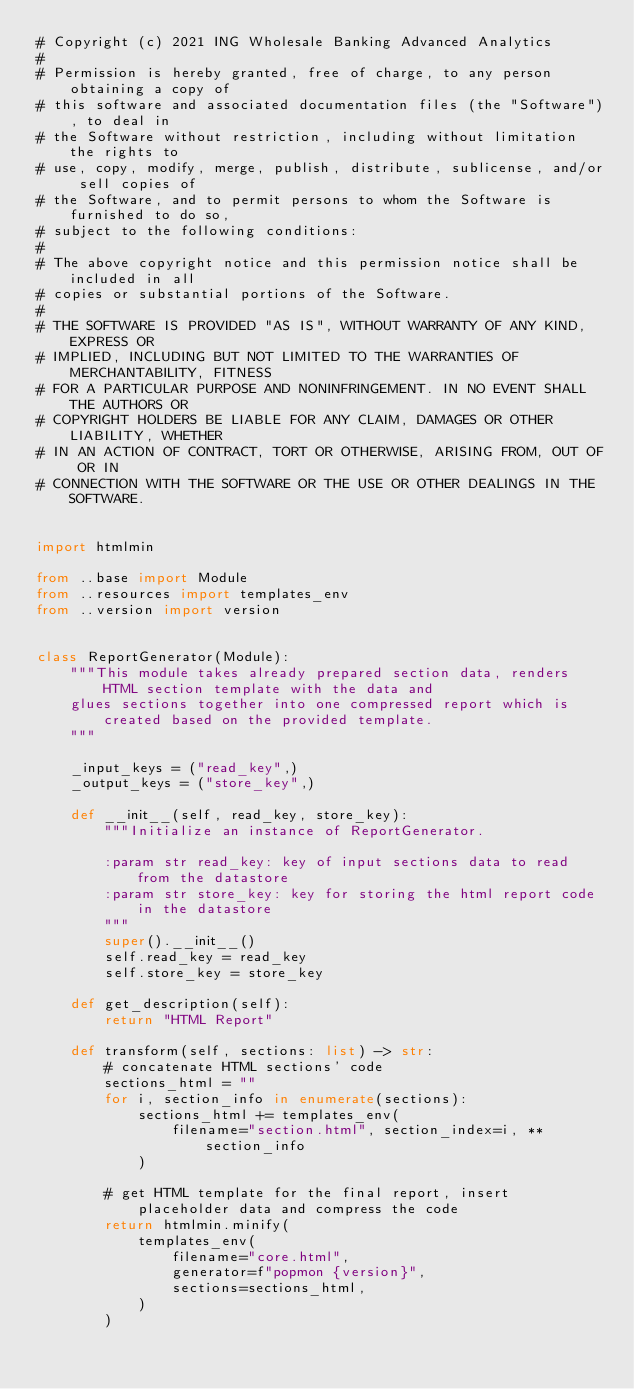Convert code to text. <code><loc_0><loc_0><loc_500><loc_500><_Python_># Copyright (c) 2021 ING Wholesale Banking Advanced Analytics
#
# Permission is hereby granted, free of charge, to any person obtaining a copy of
# this software and associated documentation files (the "Software"), to deal in
# the Software without restriction, including without limitation the rights to
# use, copy, modify, merge, publish, distribute, sublicense, and/or sell copies of
# the Software, and to permit persons to whom the Software is furnished to do so,
# subject to the following conditions:
#
# The above copyright notice and this permission notice shall be included in all
# copies or substantial portions of the Software.
#
# THE SOFTWARE IS PROVIDED "AS IS", WITHOUT WARRANTY OF ANY KIND, EXPRESS OR
# IMPLIED, INCLUDING BUT NOT LIMITED TO THE WARRANTIES OF MERCHANTABILITY, FITNESS
# FOR A PARTICULAR PURPOSE AND NONINFRINGEMENT. IN NO EVENT SHALL THE AUTHORS OR
# COPYRIGHT HOLDERS BE LIABLE FOR ANY CLAIM, DAMAGES OR OTHER LIABILITY, WHETHER
# IN AN ACTION OF CONTRACT, TORT OR OTHERWISE, ARISING FROM, OUT OF OR IN
# CONNECTION WITH THE SOFTWARE OR THE USE OR OTHER DEALINGS IN THE SOFTWARE.


import htmlmin

from ..base import Module
from ..resources import templates_env
from ..version import version


class ReportGenerator(Module):
    """This module takes already prepared section data, renders HTML section template with the data and
    glues sections together into one compressed report which is created based on the provided template.
    """

    _input_keys = ("read_key",)
    _output_keys = ("store_key",)

    def __init__(self, read_key, store_key):
        """Initialize an instance of ReportGenerator.

        :param str read_key: key of input sections data to read from the datastore
        :param str store_key: key for storing the html report code in the datastore
        """
        super().__init__()
        self.read_key = read_key
        self.store_key = store_key

    def get_description(self):
        return "HTML Report"

    def transform(self, sections: list) -> str:
        # concatenate HTML sections' code
        sections_html = ""
        for i, section_info in enumerate(sections):
            sections_html += templates_env(
                filename="section.html", section_index=i, **section_info
            )

        # get HTML template for the final report, insert placeholder data and compress the code
        return htmlmin.minify(
            templates_env(
                filename="core.html",
                generator=f"popmon {version}",
                sections=sections_html,
            )
        )
</code> 